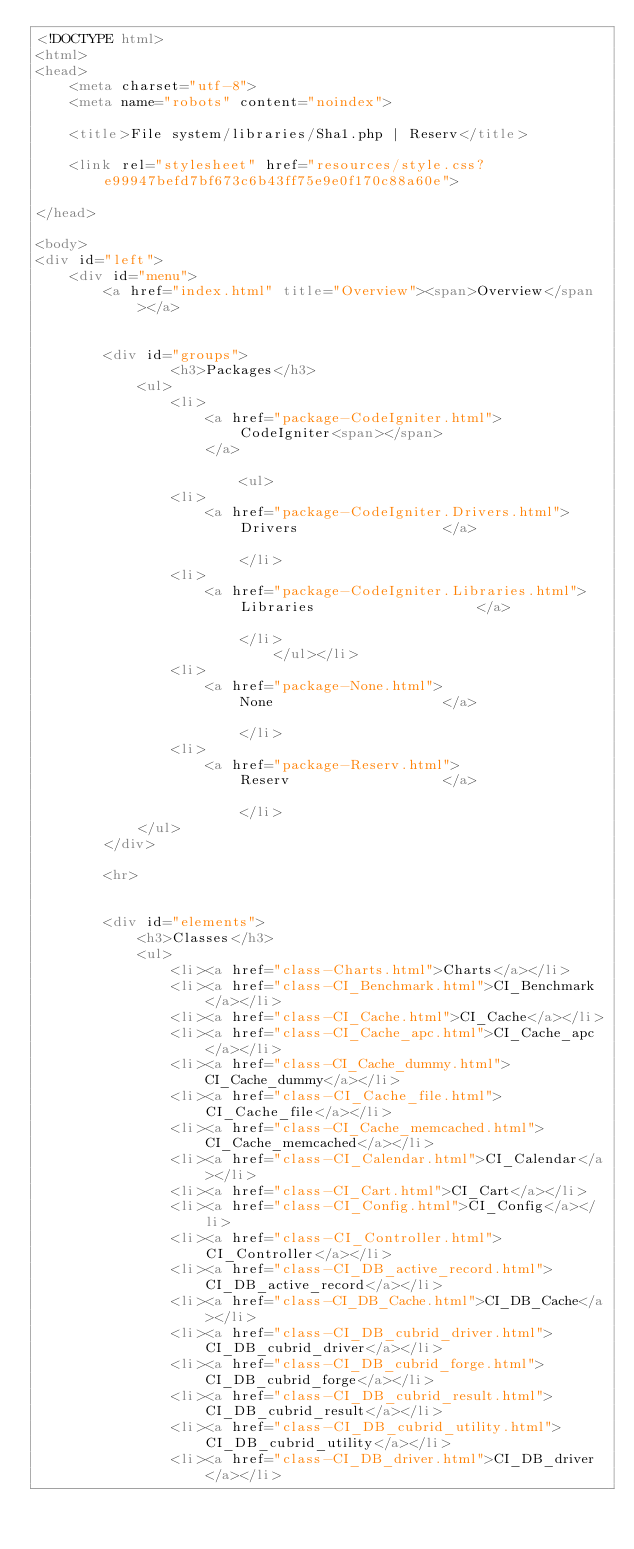Convert code to text. <code><loc_0><loc_0><loc_500><loc_500><_HTML_><!DOCTYPE html>
<html>
<head>
	<meta charset="utf-8">
	<meta name="robots" content="noindex">

	<title>File system/libraries/Sha1.php | Reserv</title>

	<link rel="stylesheet" href="resources/style.css?e99947befd7bf673c6b43ff75e9e0f170c88a60e">

</head>

<body>
<div id="left">
	<div id="menu">
		<a href="index.html" title="Overview"><span>Overview</span></a>


		<div id="groups">
				<h3>Packages</h3>
			<ul>
				<li>
					<a href="package-CodeIgniter.html">
						CodeIgniter<span></span>
					</a>

						<ul>
				<li>
					<a href="package-CodeIgniter.Drivers.html">
						Drivers					</a>

						</li>
				<li>
					<a href="package-CodeIgniter.Libraries.html">
						Libraries					</a>

						</li>
							</ul></li>
				<li>
					<a href="package-None.html">
						None					</a>

						</li>
				<li>
					<a href="package-Reserv.html">
						Reserv					</a>

						</li>
			</ul>
		</div>

		<hr>


		<div id="elements">
			<h3>Classes</h3>
			<ul>
				<li><a href="class-Charts.html">Charts</a></li>
				<li><a href="class-CI_Benchmark.html">CI_Benchmark</a></li>
				<li><a href="class-CI_Cache.html">CI_Cache</a></li>
				<li><a href="class-CI_Cache_apc.html">CI_Cache_apc</a></li>
				<li><a href="class-CI_Cache_dummy.html">CI_Cache_dummy</a></li>
				<li><a href="class-CI_Cache_file.html">CI_Cache_file</a></li>
				<li><a href="class-CI_Cache_memcached.html">CI_Cache_memcached</a></li>
				<li><a href="class-CI_Calendar.html">CI_Calendar</a></li>
				<li><a href="class-CI_Cart.html">CI_Cart</a></li>
				<li><a href="class-CI_Config.html">CI_Config</a></li>
				<li><a href="class-CI_Controller.html">CI_Controller</a></li>
				<li><a href="class-CI_DB_active_record.html">CI_DB_active_record</a></li>
				<li><a href="class-CI_DB_Cache.html">CI_DB_Cache</a></li>
				<li><a href="class-CI_DB_cubrid_driver.html">CI_DB_cubrid_driver</a></li>
				<li><a href="class-CI_DB_cubrid_forge.html">CI_DB_cubrid_forge</a></li>
				<li><a href="class-CI_DB_cubrid_result.html">CI_DB_cubrid_result</a></li>
				<li><a href="class-CI_DB_cubrid_utility.html">CI_DB_cubrid_utility</a></li>
				<li><a href="class-CI_DB_driver.html">CI_DB_driver</a></li></code> 